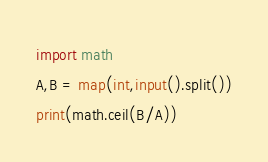<code> <loc_0><loc_0><loc_500><loc_500><_Python_>import math
A,B = map(int,input().split())
print(math.ceil(B/A))
</code> 